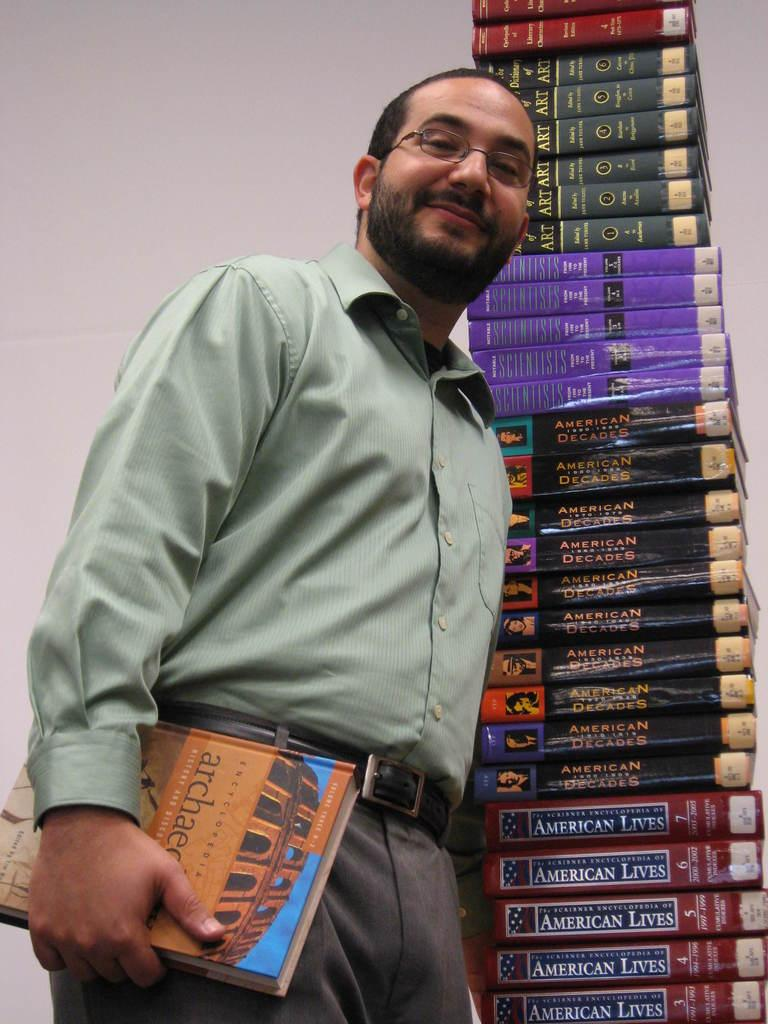<image>
Share a concise interpretation of the image provided. A man stands next to a large stack of books with some titled American Lives towards the bottom. 